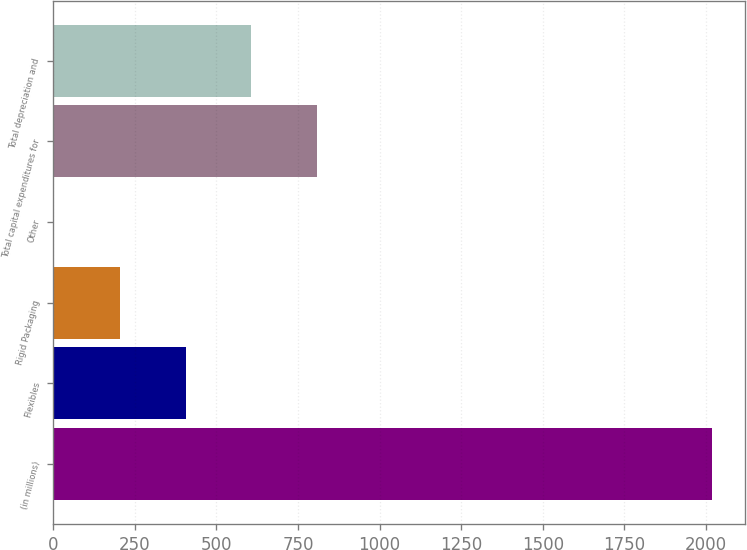Convert chart to OTSL. <chart><loc_0><loc_0><loc_500><loc_500><bar_chart><fcel>(in millions)<fcel>Flexibles<fcel>Rigid Packaging<fcel>Other<fcel>Total capital expenditures for<fcel>Total depreciation and<nl><fcel>2017<fcel>405.16<fcel>203.68<fcel>2.2<fcel>808.12<fcel>606.64<nl></chart> 